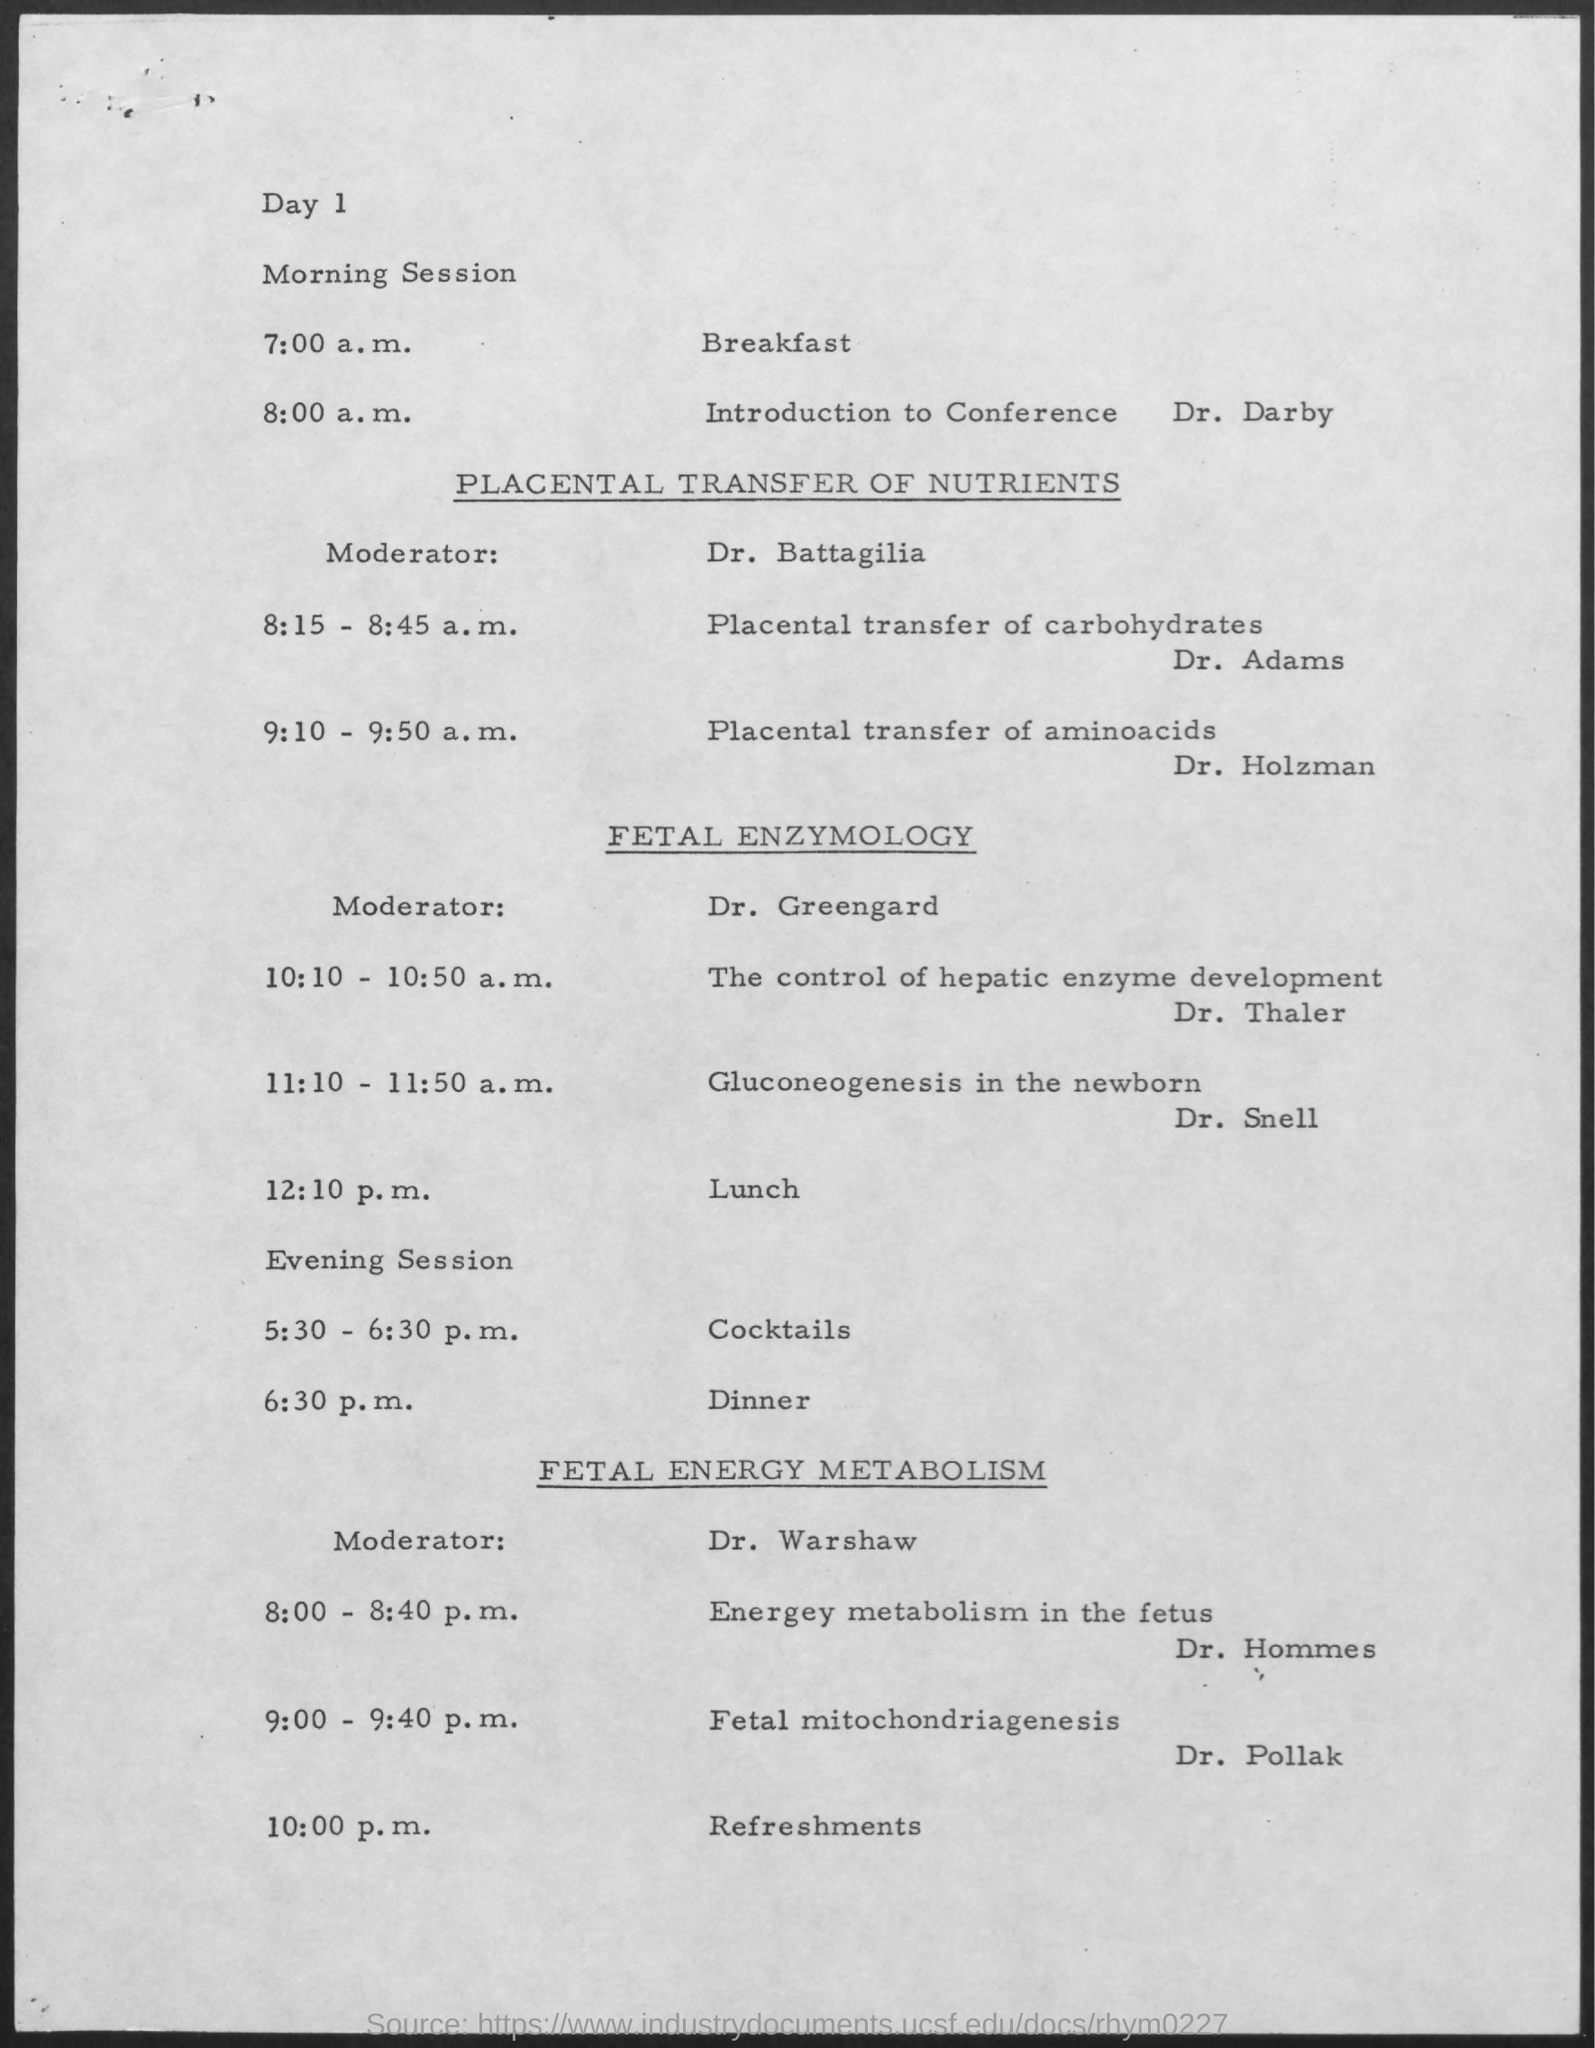What is the name of the moderator for placental transfer of nutrients ?
Your answer should be very brief. Dr. Battagilia. What is the schedule at the time of 7:00 a.m. on day 1 morning session ?
Give a very brief answer. Breakfast. What is the schedule at the time of 8:00 a.m. on day 1 morning session ?
Make the answer very short. Introduction to Conference Dr. Darby. What is the name of the moderator for fetal enzymology ?
Your response must be concise. Dr. Greengard. What is the schedule at the time of 12:10 p.m. ?
Make the answer very short. Lunch. What is the schedule at the time of 6:30 p.m. ?
Your answer should be very brief. Dinner. What is the name of the moderator for fetal energy metabolism ?
Your answer should be very brief. Dr. warshaw. What is the schedule at the time of 10:00 p.m. ?
Your answer should be compact. Refreshments. What is the schedule at the time of 5:30 - 6:30 p.m. ?
Provide a short and direct response. Cocktails. 